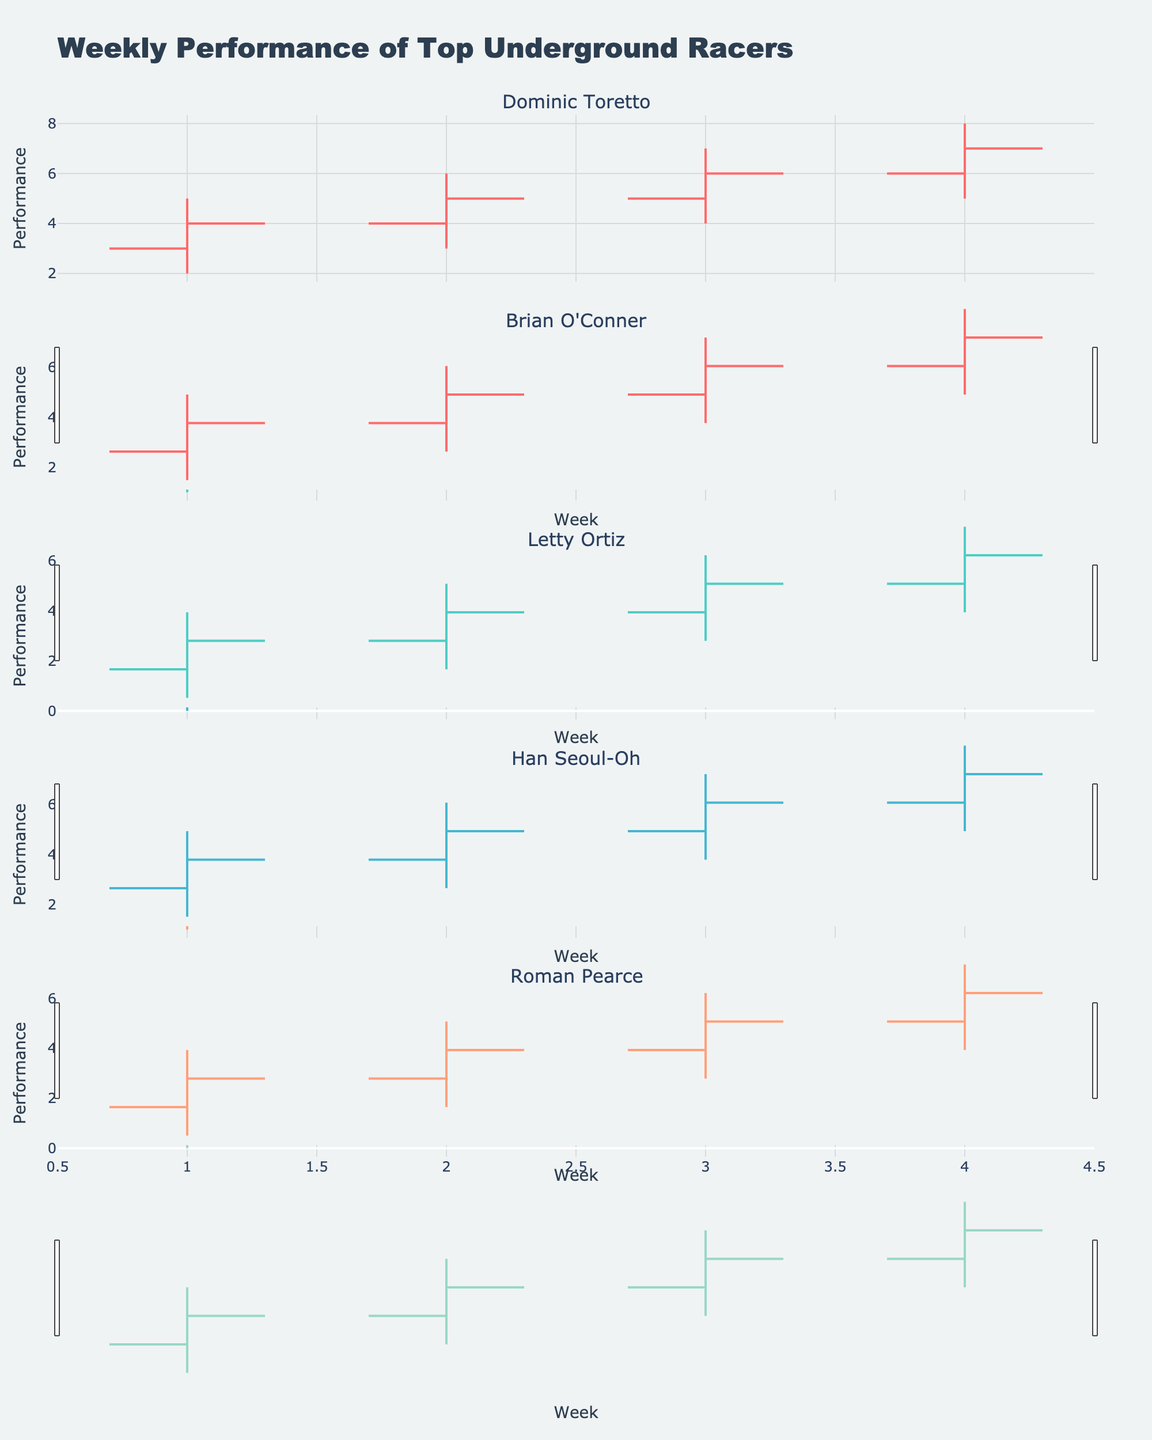what is the title of the figure? The title of the figure is displayed at the top, and it summarizes the focus of the figure, which is the weekly performance of the racers.
Answer: Weekly Performance of Top Underground Racers What is the highest performance value Letty Ortiz achieved, and in which week did this occur? Look at the OHLC charts for Letty Ortiz. The highest value is the highest point on the high line in her subplot. This value is 6, which occurred in Week 4.
Answer: 6, Week 4 How did Dominic Toretto's performance change from Week 1 to Week 4? Examine Dominic Toretto's OHLC chart from Week 1 to Week 4. Note the changes in the close values: Week 1 = 4, Week 2 = 5, Week 3 = 6, Week 4 = 7. His performance consistently increases over these weeks.
Answer: Increased Which racer had the lowest performance value in Week 1, and what was that value? Compare the low values for all racers in Week 1. Letty Ortiz and Roman Pearce both have the lowest value, which is 0.
Answer: Letty Ortiz and Roman Pearce, 0 Did any racer's performance close values stay the same between any consecutive weeks? If so, who and when? Examine the close values for each racer and check if there are any consecutive weeks where these values are the same. None of the close values for all racers remain the same from one week to the next.
Answer: None Which racer's performance showed the most overall improvement from Week 1 to Week 4? How much did their close value increase? Subtract the Week 1 close value from the Week 4 close value for each racer and find the largest difference. Dominic Toretto's performance increased the most from 4 to 7, a total of 3 points.
Answer: Dominic Toretto, 3 points Were there any weeks when Han Seoul-Oh's performance dipped below its starting value for the week? Analyze Han Seoul-Oh's OHLC chart for dips where the low value is below the open value in any week. Han Seoul-Oh’s performance dips below its starting value in Week 1 (Low < Open).
Answer: Yes, Week 1 For Brian O'Conner, in which week was the gap between his high and low performance the largest? What was the gap? Examine Brian O'Conner's OHLC chart and calculate the gap (High - Low) for each week. The largest gap is in Week 4 with a difference of 3 (7-4=3).
Answer: Week 4, Gap = 3 Name a week when Roman Pearce’s performance actually closed higher than it opened. Look at Roman Pearce's OHLC chart where the close value is higher than the open value. In Week 3 and Week 4, the close value is higher than the open value.
Answer: Week 3 and Week 4 